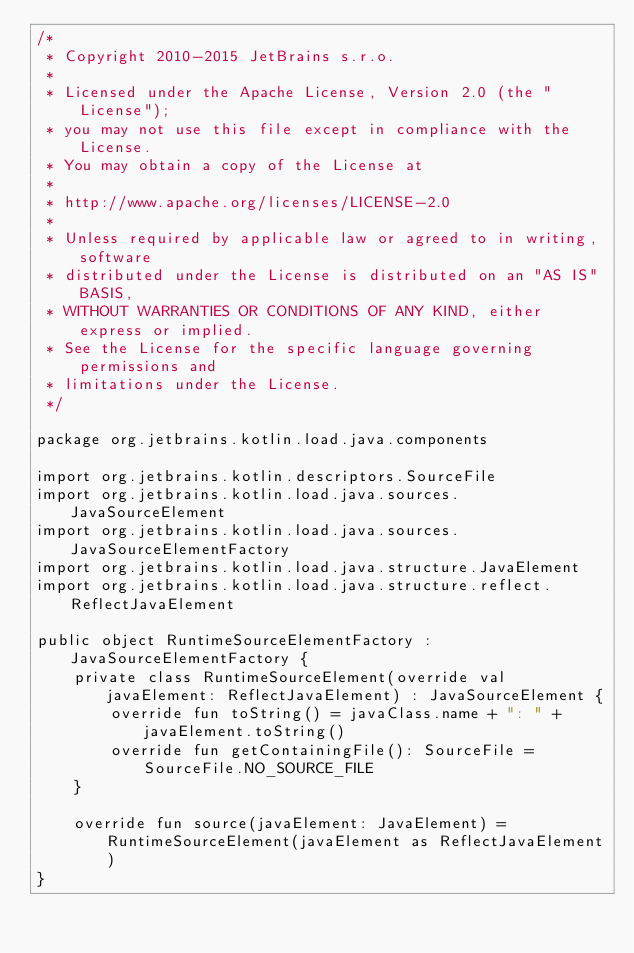Convert code to text. <code><loc_0><loc_0><loc_500><loc_500><_Kotlin_>/*
 * Copyright 2010-2015 JetBrains s.r.o.
 *
 * Licensed under the Apache License, Version 2.0 (the "License");
 * you may not use this file except in compliance with the License.
 * You may obtain a copy of the License at
 *
 * http://www.apache.org/licenses/LICENSE-2.0
 *
 * Unless required by applicable law or agreed to in writing, software
 * distributed under the License is distributed on an "AS IS" BASIS,
 * WITHOUT WARRANTIES OR CONDITIONS OF ANY KIND, either express or implied.
 * See the License for the specific language governing permissions and
 * limitations under the License.
 */

package org.jetbrains.kotlin.load.java.components

import org.jetbrains.kotlin.descriptors.SourceFile
import org.jetbrains.kotlin.load.java.sources.JavaSourceElement
import org.jetbrains.kotlin.load.java.sources.JavaSourceElementFactory
import org.jetbrains.kotlin.load.java.structure.JavaElement
import org.jetbrains.kotlin.load.java.structure.reflect.ReflectJavaElement

public object RuntimeSourceElementFactory : JavaSourceElementFactory {
    private class RuntimeSourceElement(override val javaElement: ReflectJavaElement) : JavaSourceElement {
        override fun toString() = javaClass.name + ": " + javaElement.toString()
        override fun getContainingFile(): SourceFile = SourceFile.NO_SOURCE_FILE
    }

    override fun source(javaElement: JavaElement) = RuntimeSourceElement(javaElement as ReflectJavaElement)
}
</code> 